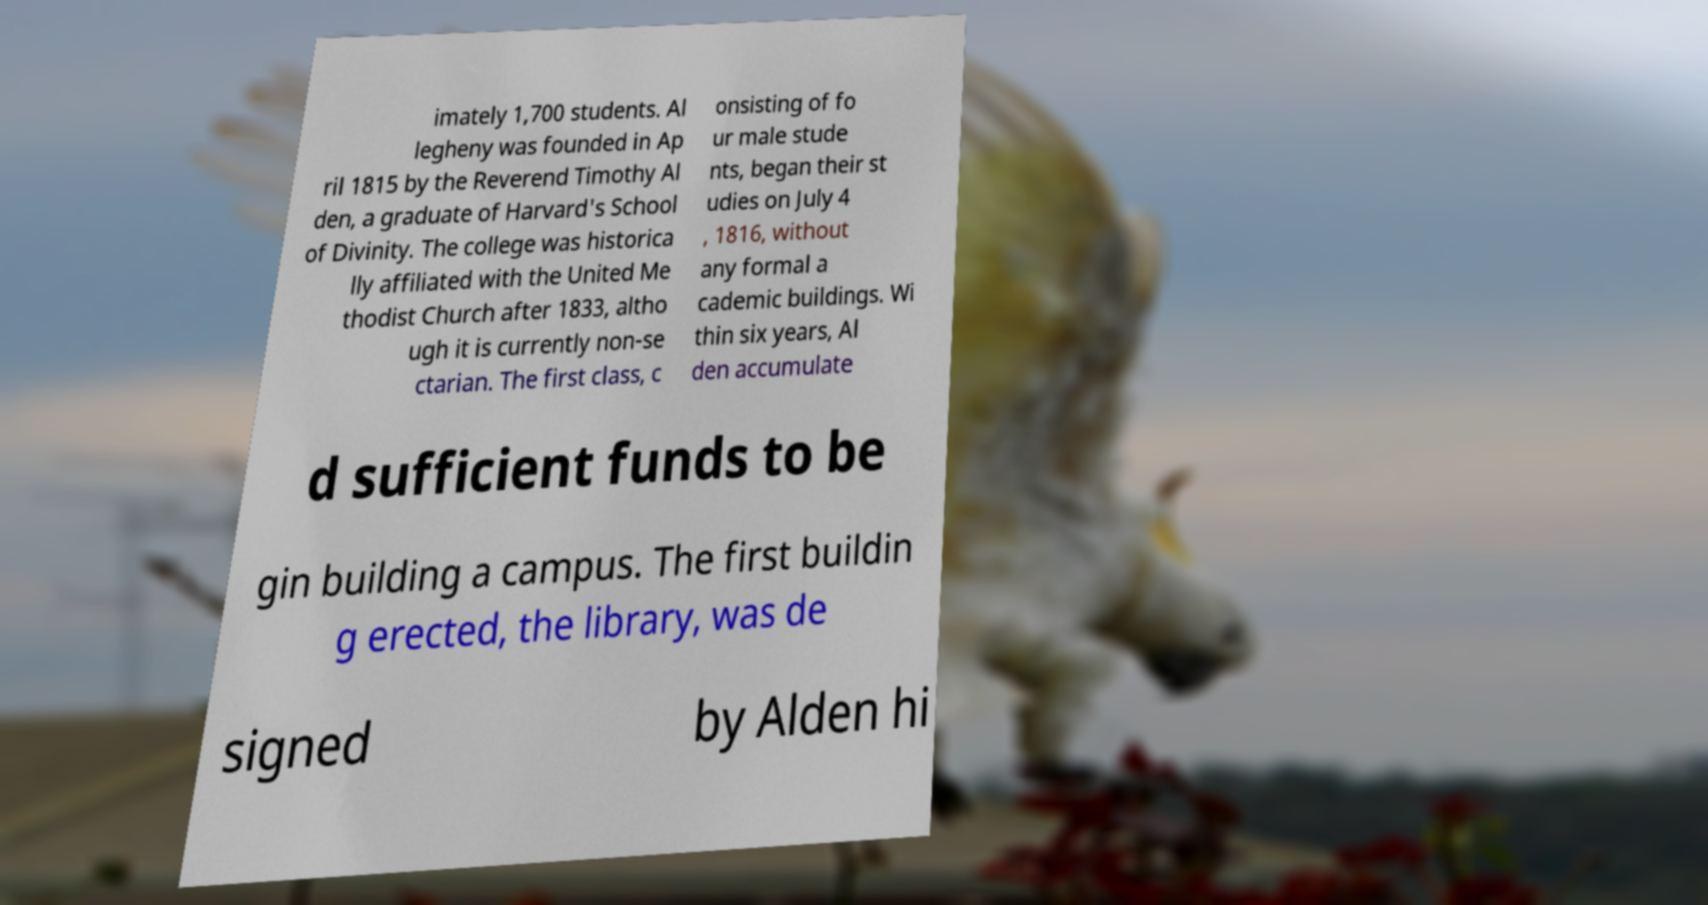Could you extract and type out the text from this image? imately 1,700 students. Al legheny was founded in Ap ril 1815 by the Reverend Timothy Al den, a graduate of Harvard's School of Divinity. The college was historica lly affiliated with the United Me thodist Church after 1833, altho ugh it is currently non-se ctarian. The first class, c onsisting of fo ur male stude nts, began their st udies on July 4 , 1816, without any formal a cademic buildings. Wi thin six years, Al den accumulate d sufficient funds to be gin building a campus. The first buildin g erected, the library, was de signed by Alden hi 